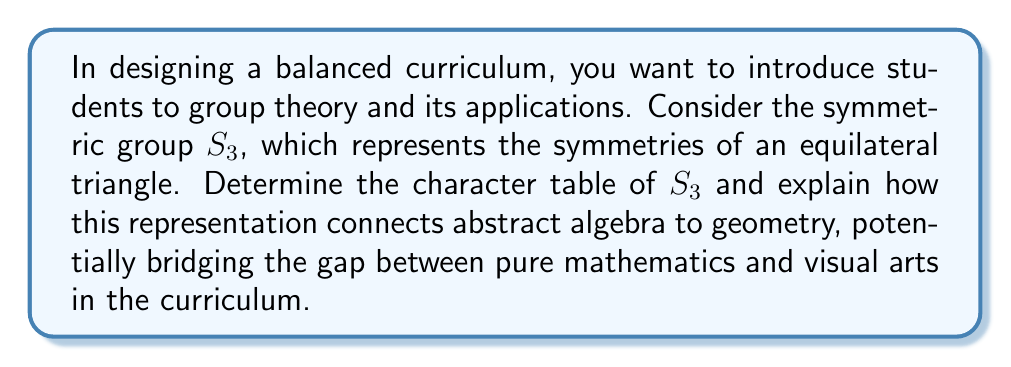Provide a solution to this math problem. To determine the character table of $S_3$ and interpret its significance, we'll follow these steps:

1) First, identify the conjugacy classes of $S_3$:
   - $C_1 = \{e\}$ (identity)
   - $C_2 = \{(12), (13), (23)\}$ (transpositions)
   - $C_3 = \{(123), (132)\}$ (3-cycles)

2) The number of irreducible representations equals the number of conjugacy classes, so $S_3$ has 3 irreducible representations.

3) The dimensions of these representations must satisfy:
   $1^2 + 1^2 + 2^2 = 6$ (order of $S_3$)
   So, we have two 1-dimensional representations and one 2-dimensional representation.

4) The character table will be a 3x3 matrix. Let's fill it in:
   - The trivial representation (all 1's)
   - The sign representation (1 for even permutations, -1 for odd)
   - The 2-dimensional representation (to be determined)

5) For the 2-dimensional representation, we can deduce:
   - $\chi(e) = 2$ (dimension of the representation)
   - $\chi((12)) = 0$ (trace of rotation by $\pi$ in 2D)
   - $\chi((123)) = -1$ (trace of rotation by $2\pi/3$ in 2D)

6) The complete character table:

   $$
   \begin{array}{c|ccc}
    S_3 & C_1 & C_2 & C_3 \\
    \hline
    \chi_1 & 1 & 1 & 1 \\
    \chi_2 & 1 & -1 & 1 \\
    \chi_3 & 2 & 0 & -1
   \end{array}
   $$

7) Interpretation:
   - $\chi_1$ represents the trivial action on the triangle.
   - $\chi_2$ distinguishes between rotations and reflections.
   - $\chi_3$ represents the geometric action on the triangle in 2D space.

This character table bridges abstract algebra and geometry by showing how the symmetric group $S_3$ acts on an equilateral triangle. It connects pure mathematics (group theory) with visual arts (geometric symmetries), demonstrating the interplay between algebra and geometry in a concrete, visualizable way.
Answer: Character table of $S_3$:
$$
\begin{array}{c|ccc}
S_3 & C_1 & C_2 & C_3 \\
\hline
\chi_1 & 1 & 1 & 1 \\
\chi_2 & 1 & -1 & 1 \\
\chi_3 & 2 & 0 & -1
\end{array}
$$
Significance: Connects group theory to geometric symmetries of a triangle. 